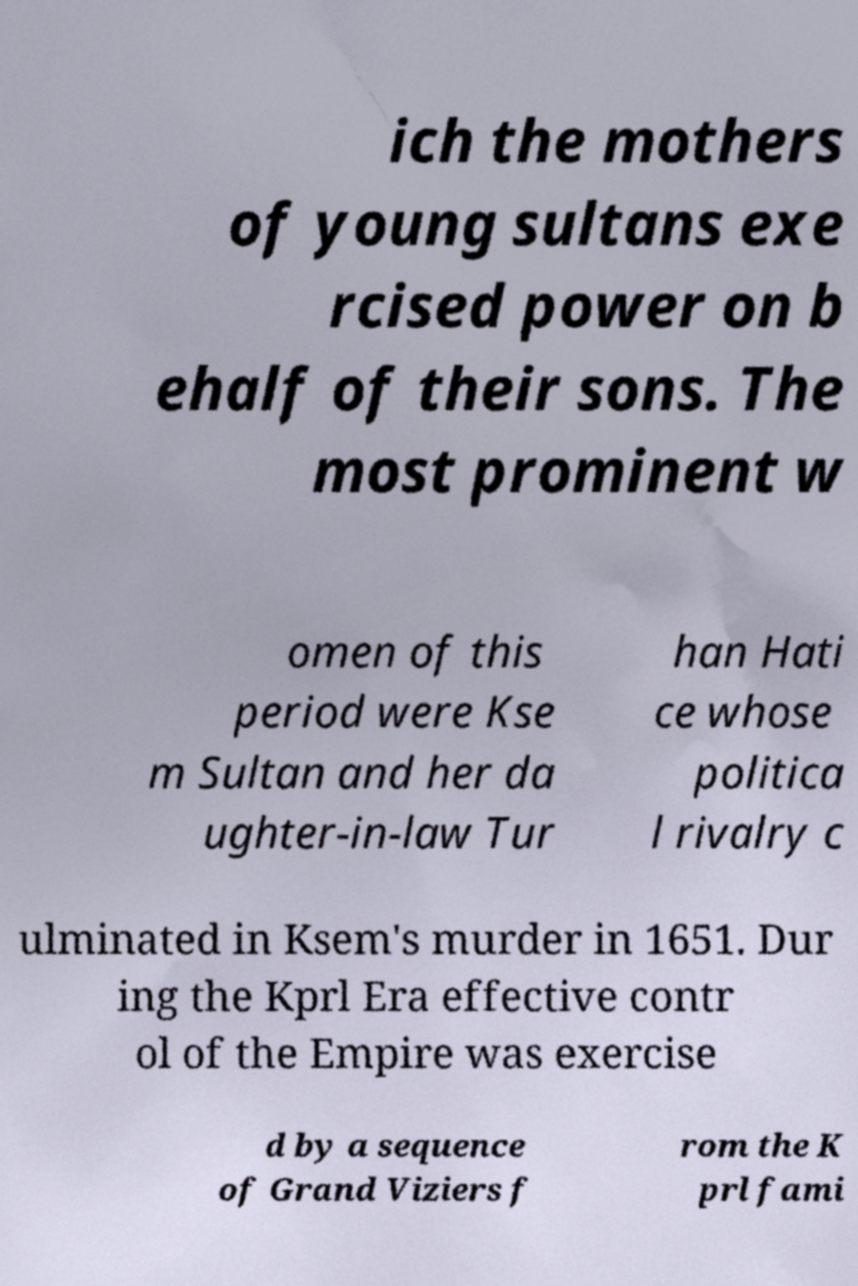What messages or text are displayed in this image? I need them in a readable, typed format. ich the mothers of young sultans exe rcised power on b ehalf of their sons. The most prominent w omen of this period were Kse m Sultan and her da ughter-in-law Tur han Hati ce whose politica l rivalry c ulminated in Ksem's murder in 1651. Dur ing the Kprl Era effective contr ol of the Empire was exercise d by a sequence of Grand Viziers f rom the K prl fami 